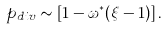<formula> <loc_0><loc_0><loc_500><loc_500>p _ { d i v } \sim \left [ { 1 - \omega ^ { * } ( \xi - 1 ) } \right ] .</formula> 